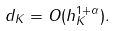<formula> <loc_0><loc_0><loc_500><loc_500>d _ { K } = O ( h _ { K } ^ { 1 + \alpha } ) .</formula> 